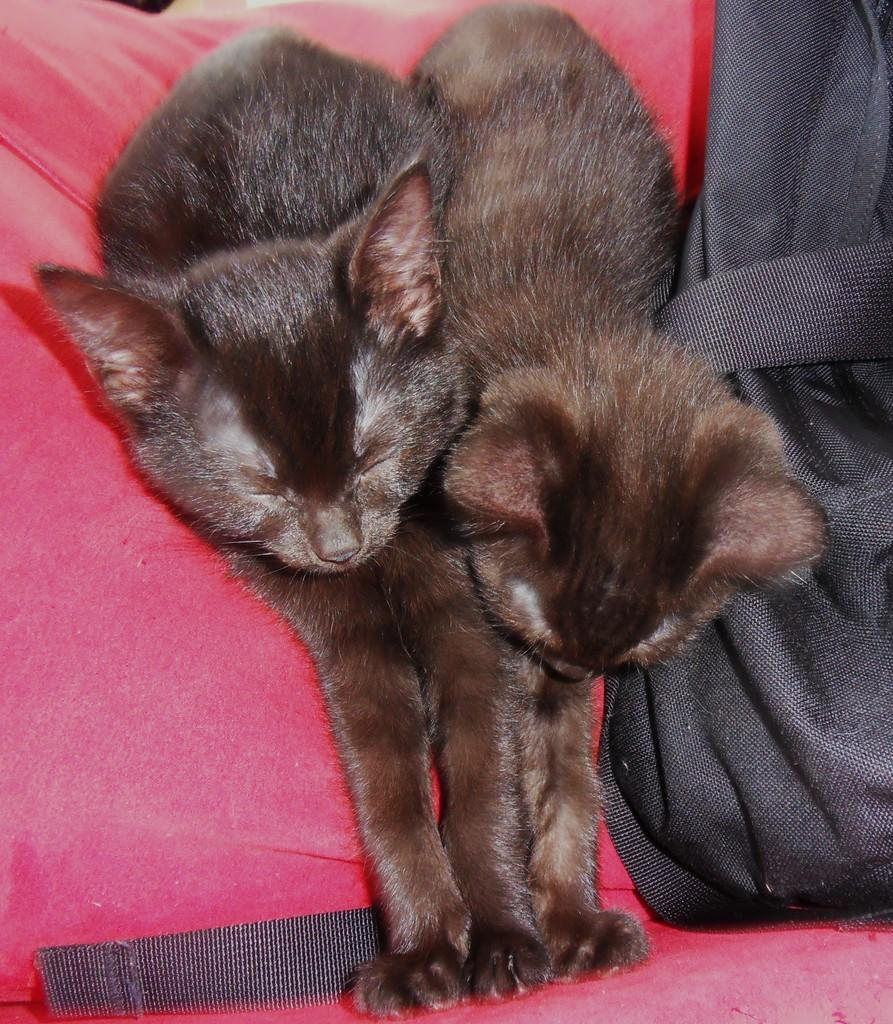What type of animals are in the image? There are cats in the image. What color are the cats? The cats are brown in color. What type of brass can be seen on the cats' toes in the image? There is no brass or reference to toes in the image; it features brown cats. 